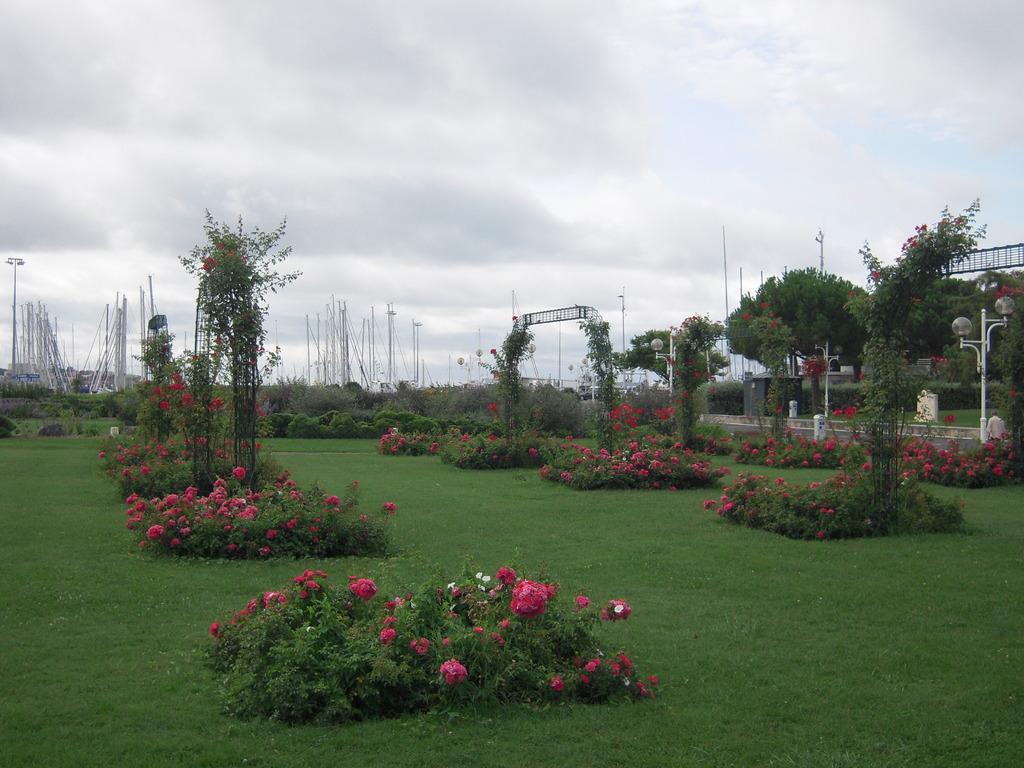Please provide a concise description of this image. In the picture we can see a garden with a grass surface and with some plants and flowers to it which are red and pink in color, in the background, we can see some poles with lights, grass plants and sky with clouds. 